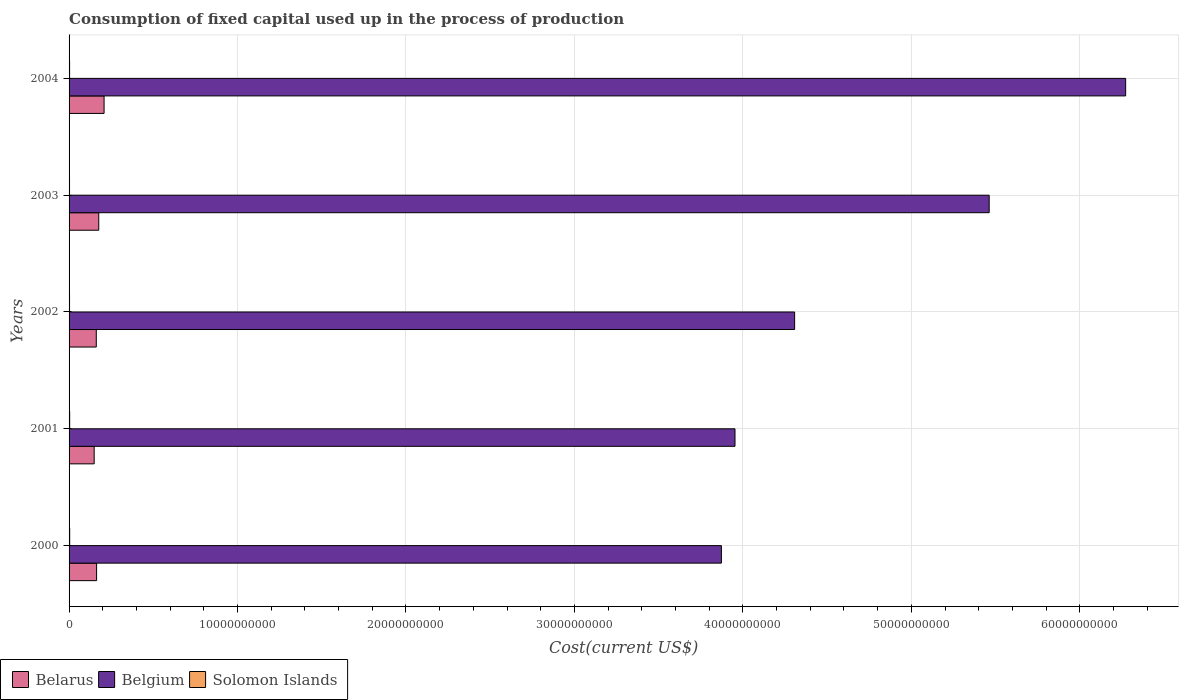How many different coloured bars are there?
Give a very brief answer. 3. Are the number of bars on each tick of the Y-axis equal?
Make the answer very short. Yes. How many bars are there on the 1st tick from the top?
Your answer should be compact. 3. How many bars are there on the 4th tick from the bottom?
Provide a short and direct response. 3. What is the label of the 3rd group of bars from the top?
Your answer should be compact. 2002. What is the amount consumed in the process of production in Belgium in 2001?
Provide a short and direct response. 3.95e+1. Across all years, what is the maximum amount consumed in the process of production in Belgium?
Your response must be concise. 6.27e+1. Across all years, what is the minimum amount consumed in the process of production in Belgium?
Ensure brevity in your answer.  3.87e+1. In which year was the amount consumed in the process of production in Solomon Islands maximum?
Offer a terse response. 2000. What is the total amount consumed in the process of production in Belarus in the graph?
Offer a very short reply. 8.58e+09. What is the difference between the amount consumed in the process of production in Belarus in 2001 and that in 2002?
Keep it short and to the point. -1.25e+08. What is the difference between the amount consumed in the process of production in Belarus in 2000 and the amount consumed in the process of production in Belgium in 2002?
Provide a short and direct response. -4.14e+1. What is the average amount consumed in the process of production in Solomon Islands per year?
Offer a very short reply. 3.19e+07. In the year 2003, what is the difference between the amount consumed in the process of production in Belarus and amount consumed in the process of production in Solomon Islands?
Your response must be concise. 1.73e+09. What is the ratio of the amount consumed in the process of production in Solomon Islands in 2000 to that in 2002?
Your response must be concise. 1.29. Is the amount consumed in the process of production in Belarus in 2000 less than that in 2004?
Your answer should be very brief. Yes. What is the difference between the highest and the second highest amount consumed in the process of production in Solomon Islands?
Provide a short and direct response. 1.70e+06. What is the difference between the highest and the lowest amount consumed in the process of production in Solomon Islands?
Provide a short and direct response. 9.81e+06. In how many years, is the amount consumed in the process of production in Belgium greater than the average amount consumed in the process of production in Belgium taken over all years?
Offer a terse response. 2. What does the 3rd bar from the bottom in 2000 represents?
Provide a succinct answer. Solomon Islands. Is it the case that in every year, the sum of the amount consumed in the process of production in Belarus and amount consumed in the process of production in Belgium is greater than the amount consumed in the process of production in Solomon Islands?
Provide a succinct answer. Yes. How many bars are there?
Offer a very short reply. 15. Are all the bars in the graph horizontal?
Make the answer very short. Yes. How many years are there in the graph?
Ensure brevity in your answer.  5. What is the difference between two consecutive major ticks on the X-axis?
Give a very brief answer. 1.00e+1. Are the values on the major ticks of X-axis written in scientific E-notation?
Your response must be concise. No. Does the graph contain any zero values?
Offer a terse response. No. How many legend labels are there?
Make the answer very short. 3. How are the legend labels stacked?
Keep it short and to the point. Horizontal. What is the title of the graph?
Your answer should be compact. Consumption of fixed capital used up in the process of production. What is the label or title of the X-axis?
Your response must be concise. Cost(current US$). What is the label or title of the Y-axis?
Offer a terse response. Years. What is the Cost(current US$) of Belarus in 2000?
Your answer should be compact. 1.63e+09. What is the Cost(current US$) of Belgium in 2000?
Your response must be concise. 3.87e+1. What is the Cost(current US$) in Solomon Islands in 2000?
Give a very brief answer. 3.70e+07. What is the Cost(current US$) of Belarus in 2001?
Your answer should be compact. 1.49e+09. What is the Cost(current US$) of Belgium in 2001?
Offer a terse response. 3.95e+1. What is the Cost(current US$) of Solomon Islands in 2001?
Offer a very short reply. 3.53e+07. What is the Cost(current US$) in Belarus in 2002?
Give a very brief answer. 1.61e+09. What is the Cost(current US$) in Belgium in 2002?
Give a very brief answer. 4.31e+1. What is the Cost(current US$) in Solomon Islands in 2002?
Make the answer very short. 2.87e+07. What is the Cost(current US$) in Belarus in 2003?
Your answer should be compact. 1.76e+09. What is the Cost(current US$) in Belgium in 2003?
Your answer should be very brief. 5.46e+1. What is the Cost(current US$) in Solomon Islands in 2003?
Offer a terse response. 2.71e+07. What is the Cost(current US$) of Belarus in 2004?
Give a very brief answer. 2.08e+09. What is the Cost(current US$) of Belgium in 2004?
Your response must be concise. 6.27e+1. What is the Cost(current US$) of Solomon Islands in 2004?
Offer a very short reply. 3.13e+07. Across all years, what is the maximum Cost(current US$) in Belarus?
Provide a succinct answer. 2.08e+09. Across all years, what is the maximum Cost(current US$) in Belgium?
Your answer should be very brief. 6.27e+1. Across all years, what is the maximum Cost(current US$) of Solomon Islands?
Make the answer very short. 3.70e+07. Across all years, what is the minimum Cost(current US$) in Belarus?
Ensure brevity in your answer.  1.49e+09. Across all years, what is the minimum Cost(current US$) in Belgium?
Keep it short and to the point. 3.87e+1. Across all years, what is the minimum Cost(current US$) in Solomon Islands?
Make the answer very short. 2.71e+07. What is the total Cost(current US$) in Belarus in the graph?
Provide a succinct answer. 8.58e+09. What is the total Cost(current US$) in Belgium in the graph?
Keep it short and to the point. 2.39e+11. What is the total Cost(current US$) in Solomon Islands in the graph?
Provide a short and direct response. 1.59e+08. What is the difference between the Cost(current US$) of Belarus in 2000 and that in 2001?
Provide a succinct answer. 1.44e+08. What is the difference between the Cost(current US$) in Belgium in 2000 and that in 2001?
Provide a succinct answer. -8.08e+08. What is the difference between the Cost(current US$) of Solomon Islands in 2000 and that in 2001?
Offer a terse response. 1.70e+06. What is the difference between the Cost(current US$) of Belarus in 2000 and that in 2002?
Offer a very short reply. 1.91e+07. What is the difference between the Cost(current US$) in Belgium in 2000 and that in 2002?
Make the answer very short. -4.35e+09. What is the difference between the Cost(current US$) of Solomon Islands in 2000 and that in 2002?
Your answer should be compact. 8.28e+06. What is the difference between the Cost(current US$) in Belarus in 2000 and that in 2003?
Provide a succinct answer. -1.28e+08. What is the difference between the Cost(current US$) in Belgium in 2000 and that in 2003?
Your answer should be very brief. -1.59e+1. What is the difference between the Cost(current US$) in Solomon Islands in 2000 and that in 2003?
Give a very brief answer. 9.81e+06. What is the difference between the Cost(current US$) of Belarus in 2000 and that in 2004?
Make the answer very short. -4.44e+08. What is the difference between the Cost(current US$) of Belgium in 2000 and that in 2004?
Your response must be concise. -2.40e+1. What is the difference between the Cost(current US$) of Solomon Islands in 2000 and that in 2004?
Offer a terse response. 5.64e+06. What is the difference between the Cost(current US$) in Belarus in 2001 and that in 2002?
Make the answer very short. -1.25e+08. What is the difference between the Cost(current US$) of Belgium in 2001 and that in 2002?
Give a very brief answer. -3.54e+09. What is the difference between the Cost(current US$) of Solomon Islands in 2001 and that in 2002?
Offer a terse response. 6.58e+06. What is the difference between the Cost(current US$) in Belarus in 2001 and that in 2003?
Provide a short and direct response. -2.72e+08. What is the difference between the Cost(current US$) in Belgium in 2001 and that in 2003?
Offer a very short reply. -1.51e+1. What is the difference between the Cost(current US$) of Solomon Islands in 2001 and that in 2003?
Ensure brevity in your answer.  8.11e+06. What is the difference between the Cost(current US$) in Belarus in 2001 and that in 2004?
Ensure brevity in your answer.  -5.88e+08. What is the difference between the Cost(current US$) of Belgium in 2001 and that in 2004?
Provide a short and direct response. -2.32e+1. What is the difference between the Cost(current US$) of Solomon Islands in 2001 and that in 2004?
Offer a terse response. 3.94e+06. What is the difference between the Cost(current US$) in Belarus in 2002 and that in 2003?
Offer a terse response. -1.47e+08. What is the difference between the Cost(current US$) of Belgium in 2002 and that in 2003?
Provide a short and direct response. -1.16e+1. What is the difference between the Cost(current US$) of Solomon Islands in 2002 and that in 2003?
Provide a short and direct response. 1.54e+06. What is the difference between the Cost(current US$) in Belarus in 2002 and that in 2004?
Ensure brevity in your answer.  -4.63e+08. What is the difference between the Cost(current US$) of Belgium in 2002 and that in 2004?
Offer a terse response. -1.97e+1. What is the difference between the Cost(current US$) in Solomon Islands in 2002 and that in 2004?
Your answer should be very brief. -2.64e+06. What is the difference between the Cost(current US$) of Belarus in 2003 and that in 2004?
Your response must be concise. -3.16e+08. What is the difference between the Cost(current US$) of Belgium in 2003 and that in 2004?
Keep it short and to the point. -8.10e+09. What is the difference between the Cost(current US$) in Solomon Islands in 2003 and that in 2004?
Give a very brief answer. -4.17e+06. What is the difference between the Cost(current US$) of Belarus in 2000 and the Cost(current US$) of Belgium in 2001?
Make the answer very short. -3.79e+1. What is the difference between the Cost(current US$) of Belarus in 2000 and the Cost(current US$) of Solomon Islands in 2001?
Provide a succinct answer. 1.60e+09. What is the difference between the Cost(current US$) in Belgium in 2000 and the Cost(current US$) in Solomon Islands in 2001?
Give a very brief answer. 3.87e+1. What is the difference between the Cost(current US$) in Belarus in 2000 and the Cost(current US$) in Belgium in 2002?
Your answer should be compact. -4.14e+1. What is the difference between the Cost(current US$) of Belarus in 2000 and the Cost(current US$) of Solomon Islands in 2002?
Keep it short and to the point. 1.61e+09. What is the difference between the Cost(current US$) in Belgium in 2000 and the Cost(current US$) in Solomon Islands in 2002?
Provide a short and direct response. 3.87e+1. What is the difference between the Cost(current US$) of Belarus in 2000 and the Cost(current US$) of Belgium in 2003?
Provide a succinct answer. -5.30e+1. What is the difference between the Cost(current US$) in Belarus in 2000 and the Cost(current US$) in Solomon Islands in 2003?
Your answer should be compact. 1.61e+09. What is the difference between the Cost(current US$) in Belgium in 2000 and the Cost(current US$) in Solomon Islands in 2003?
Your answer should be very brief. 3.87e+1. What is the difference between the Cost(current US$) in Belarus in 2000 and the Cost(current US$) in Belgium in 2004?
Your response must be concise. -6.11e+1. What is the difference between the Cost(current US$) of Belarus in 2000 and the Cost(current US$) of Solomon Islands in 2004?
Keep it short and to the point. 1.60e+09. What is the difference between the Cost(current US$) of Belgium in 2000 and the Cost(current US$) of Solomon Islands in 2004?
Offer a terse response. 3.87e+1. What is the difference between the Cost(current US$) of Belarus in 2001 and the Cost(current US$) of Belgium in 2002?
Offer a very short reply. -4.16e+1. What is the difference between the Cost(current US$) in Belarus in 2001 and the Cost(current US$) in Solomon Islands in 2002?
Keep it short and to the point. 1.46e+09. What is the difference between the Cost(current US$) in Belgium in 2001 and the Cost(current US$) in Solomon Islands in 2002?
Keep it short and to the point. 3.95e+1. What is the difference between the Cost(current US$) in Belarus in 2001 and the Cost(current US$) in Belgium in 2003?
Ensure brevity in your answer.  -5.31e+1. What is the difference between the Cost(current US$) of Belarus in 2001 and the Cost(current US$) of Solomon Islands in 2003?
Your answer should be very brief. 1.46e+09. What is the difference between the Cost(current US$) in Belgium in 2001 and the Cost(current US$) in Solomon Islands in 2003?
Ensure brevity in your answer.  3.95e+1. What is the difference between the Cost(current US$) in Belarus in 2001 and the Cost(current US$) in Belgium in 2004?
Your answer should be compact. -6.12e+1. What is the difference between the Cost(current US$) in Belarus in 2001 and the Cost(current US$) in Solomon Islands in 2004?
Keep it short and to the point. 1.46e+09. What is the difference between the Cost(current US$) in Belgium in 2001 and the Cost(current US$) in Solomon Islands in 2004?
Keep it short and to the point. 3.95e+1. What is the difference between the Cost(current US$) of Belarus in 2002 and the Cost(current US$) of Belgium in 2003?
Your answer should be very brief. -5.30e+1. What is the difference between the Cost(current US$) in Belarus in 2002 and the Cost(current US$) in Solomon Islands in 2003?
Your answer should be very brief. 1.59e+09. What is the difference between the Cost(current US$) in Belgium in 2002 and the Cost(current US$) in Solomon Islands in 2003?
Keep it short and to the point. 4.30e+1. What is the difference between the Cost(current US$) of Belarus in 2002 and the Cost(current US$) of Belgium in 2004?
Give a very brief answer. -6.11e+1. What is the difference between the Cost(current US$) in Belarus in 2002 and the Cost(current US$) in Solomon Islands in 2004?
Make the answer very short. 1.58e+09. What is the difference between the Cost(current US$) of Belgium in 2002 and the Cost(current US$) of Solomon Islands in 2004?
Provide a short and direct response. 4.30e+1. What is the difference between the Cost(current US$) in Belarus in 2003 and the Cost(current US$) in Belgium in 2004?
Provide a succinct answer. -6.10e+1. What is the difference between the Cost(current US$) in Belarus in 2003 and the Cost(current US$) in Solomon Islands in 2004?
Provide a short and direct response. 1.73e+09. What is the difference between the Cost(current US$) in Belgium in 2003 and the Cost(current US$) in Solomon Islands in 2004?
Your response must be concise. 5.46e+1. What is the average Cost(current US$) of Belarus per year?
Your response must be concise. 1.72e+09. What is the average Cost(current US$) of Belgium per year?
Give a very brief answer. 4.77e+1. What is the average Cost(current US$) in Solomon Islands per year?
Make the answer very short. 3.19e+07. In the year 2000, what is the difference between the Cost(current US$) in Belarus and Cost(current US$) in Belgium?
Provide a succinct answer. -3.71e+1. In the year 2000, what is the difference between the Cost(current US$) of Belarus and Cost(current US$) of Solomon Islands?
Your answer should be compact. 1.60e+09. In the year 2000, what is the difference between the Cost(current US$) in Belgium and Cost(current US$) in Solomon Islands?
Ensure brevity in your answer.  3.87e+1. In the year 2001, what is the difference between the Cost(current US$) in Belarus and Cost(current US$) in Belgium?
Give a very brief answer. -3.80e+1. In the year 2001, what is the difference between the Cost(current US$) of Belarus and Cost(current US$) of Solomon Islands?
Your response must be concise. 1.45e+09. In the year 2001, what is the difference between the Cost(current US$) of Belgium and Cost(current US$) of Solomon Islands?
Give a very brief answer. 3.95e+1. In the year 2002, what is the difference between the Cost(current US$) of Belarus and Cost(current US$) of Belgium?
Your response must be concise. -4.15e+1. In the year 2002, what is the difference between the Cost(current US$) of Belarus and Cost(current US$) of Solomon Islands?
Your response must be concise. 1.59e+09. In the year 2002, what is the difference between the Cost(current US$) of Belgium and Cost(current US$) of Solomon Islands?
Provide a short and direct response. 4.30e+1. In the year 2003, what is the difference between the Cost(current US$) of Belarus and Cost(current US$) of Belgium?
Your response must be concise. -5.29e+1. In the year 2003, what is the difference between the Cost(current US$) in Belarus and Cost(current US$) in Solomon Islands?
Your response must be concise. 1.73e+09. In the year 2003, what is the difference between the Cost(current US$) of Belgium and Cost(current US$) of Solomon Islands?
Your answer should be very brief. 5.46e+1. In the year 2004, what is the difference between the Cost(current US$) in Belarus and Cost(current US$) in Belgium?
Offer a terse response. -6.06e+1. In the year 2004, what is the difference between the Cost(current US$) in Belarus and Cost(current US$) in Solomon Islands?
Provide a succinct answer. 2.05e+09. In the year 2004, what is the difference between the Cost(current US$) of Belgium and Cost(current US$) of Solomon Islands?
Give a very brief answer. 6.27e+1. What is the ratio of the Cost(current US$) of Belarus in 2000 to that in 2001?
Offer a very short reply. 1.1. What is the ratio of the Cost(current US$) in Belgium in 2000 to that in 2001?
Give a very brief answer. 0.98. What is the ratio of the Cost(current US$) of Solomon Islands in 2000 to that in 2001?
Make the answer very short. 1.05. What is the ratio of the Cost(current US$) of Belarus in 2000 to that in 2002?
Ensure brevity in your answer.  1.01. What is the ratio of the Cost(current US$) in Belgium in 2000 to that in 2002?
Your answer should be very brief. 0.9. What is the ratio of the Cost(current US$) in Solomon Islands in 2000 to that in 2002?
Give a very brief answer. 1.29. What is the ratio of the Cost(current US$) of Belarus in 2000 to that in 2003?
Your response must be concise. 0.93. What is the ratio of the Cost(current US$) of Belgium in 2000 to that in 2003?
Your answer should be compact. 0.71. What is the ratio of the Cost(current US$) in Solomon Islands in 2000 to that in 2003?
Ensure brevity in your answer.  1.36. What is the ratio of the Cost(current US$) of Belarus in 2000 to that in 2004?
Offer a terse response. 0.79. What is the ratio of the Cost(current US$) of Belgium in 2000 to that in 2004?
Make the answer very short. 0.62. What is the ratio of the Cost(current US$) of Solomon Islands in 2000 to that in 2004?
Ensure brevity in your answer.  1.18. What is the ratio of the Cost(current US$) in Belarus in 2001 to that in 2002?
Provide a succinct answer. 0.92. What is the ratio of the Cost(current US$) of Belgium in 2001 to that in 2002?
Provide a short and direct response. 0.92. What is the ratio of the Cost(current US$) of Solomon Islands in 2001 to that in 2002?
Ensure brevity in your answer.  1.23. What is the ratio of the Cost(current US$) of Belarus in 2001 to that in 2003?
Give a very brief answer. 0.85. What is the ratio of the Cost(current US$) in Belgium in 2001 to that in 2003?
Offer a very short reply. 0.72. What is the ratio of the Cost(current US$) in Solomon Islands in 2001 to that in 2003?
Provide a short and direct response. 1.3. What is the ratio of the Cost(current US$) in Belarus in 2001 to that in 2004?
Offer a terse response. 0.72. What is the ratio of the Cost(current US$) in Belgium in 2001 to that in 2004?
Offer a very short reply. 0.63. What is the ratio of the Cost(current US$) of Solomon Islands in 2001 to that in 2004?
Give a very brief answer. 1.13. What is the ratio of the Cost(current US$) in Belarus in 2002 to that in 2003?
Your response must be concise. 0.92. What is the ratio of the Cost(current US$) in Belgium in 2002 to that in 2003?
Ensure brevity in your answer.  0.79. What is the ratio of the Cost(current US$) in Solomon Islands in 2002 to that in 2003?
Make the answer very short. 1.06. What is the ratio of the Cost(current US$) of Belarus in 2002 to that in 2004?
Offer a very short reply. 0.78. What is the ratio of the Cost(current US$) of Belgium in 2002 to that in 2004?
Your answer should be very brief. 0.69. What is the ratio of the Cost(current US$) of Solomon Islands in 2002 to that in 2004?
Your answer should be very brief. 0.92. What is the ratio of the Cost(current US$) of Belarus in 2003 to that in 2004?
Your answer should be very brief. 0.85. What is the ratio of the Cost(current US$) of Belgium in 2003 to that in 2004?
Provide a succinct answer. 0.87. What is the ratio of the Cost(current US$) in Solomon Islands in 2003 to that in 2004?
Offer a very short reply. 0.87. What is the difference between the highest and the second highest Cost(current US$) of Belarus?
Give a very brief answer. 3.16e+08. What is the difference between the highest and the second highest Cost(current US$) in Belgium?
Ensure brevity in your answer.  8.10e+09. What is the difference between the highest and the second highest Cost(current US$) in Solomon Islands?
Provide a short and direct response. 1.70e+06. What is the difference between the highest and the lowest Cost(current US$) of Belarus?
Your answer should be very brief. 5.88e+08. What is the difference between the highest and the lowest Cost(current US$) of Belgium?
Offer a very short reply. 2.40e+1. What is the difference between the highest and the lowest Cost(current US$) in Solomon Islands?
Your response must be concise. 9.81e+06. 